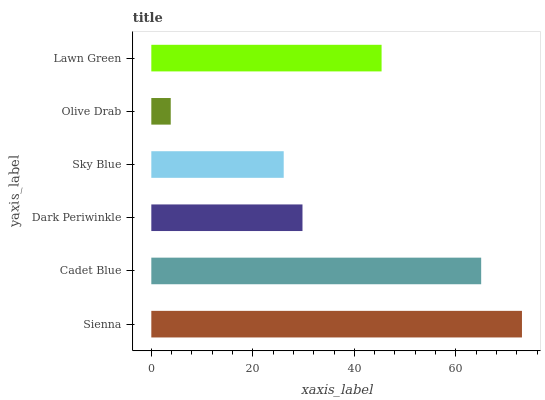Is Olive Drab the minimum?
Answer yes or no. Yes. Is Sienna the maximum?
Answer yes or no. Yes. Is Cadet Blue the minimum?
Answer yes or no. No. Is Cadet Blue the maximum?
Answer yes or no. No. Is Sienna greater than Cadet Blue?
Answer yes or no. Yes. Is Cadet Blue less than Sienna?
Answer yes or no. Yes. Is Cadet Blue greater than Sienna?
Answer yes or no. No. Is Sienna less than Cadet Blue?
Answer yes or no. No. Is Lawn Green the high median?
Answer yes or no. Yes. Is Dark Periwinkle the low median?
Answer yes or no. Yes. Is Sienna the high median?
Answer yes or no. No. Is Cadet Blue the low median?
Answer yes or no. No. 